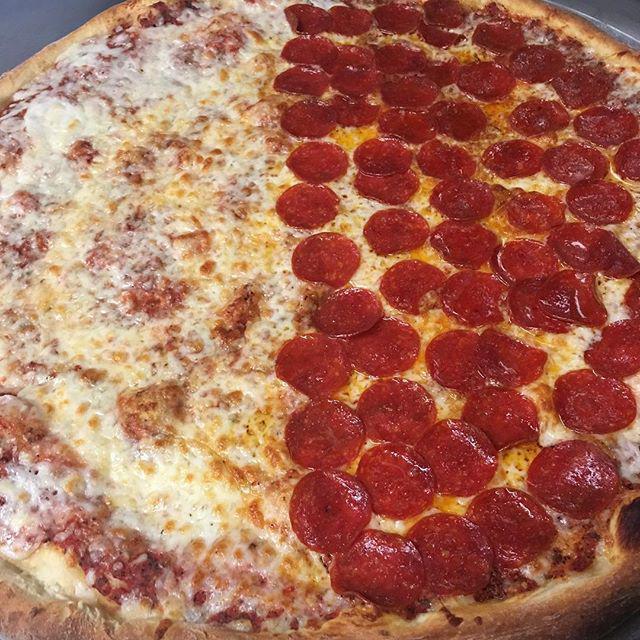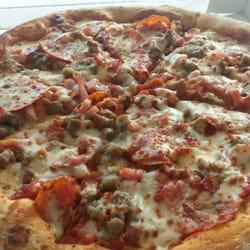The first image is the image on the left, the second image is the image on the right. Analyze the images presented: Is the assertion "All pizzas are round and no individual pizzas have different toppings on different sides." valid? Answer yes or no. No. The first image is the image on the left, the second image is the image on the right. Assess this claim about the two images: "One of the pizzas has mushrooms on top of the pepperoni toppings.". Correct or not? Answer yes or no. No. 